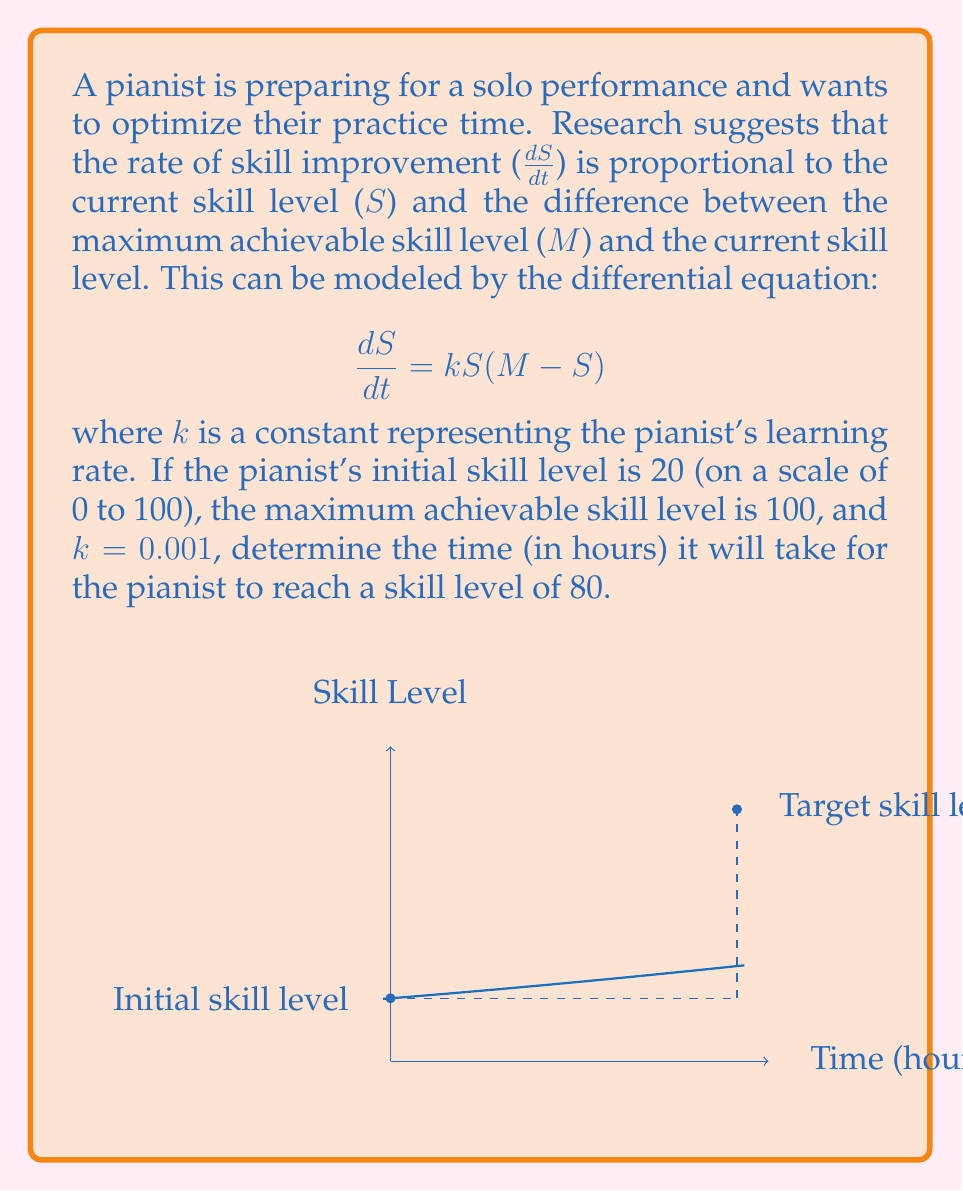Can you solve this math problem? Let's solve this problem step by step:

1) We start with the differential equation:
   $$\frac{dS}{dt} = kS(M-S)$$

2) This is a separable differential equation. We can rewrite it as:
   $$\frac{dS}{S(M-S)} = k dt$$

3) Integrating both sides:
   $$\int \frac{dS}{S(M-S)} = \int k dt$$

4) The left side can be integrated using partial fractions:
   $$\frac{1}{M} \ln|\frac{S}{M-S}| = kt + C$$

5) Solving for S:
   $$S = \frac{M}{1 + Ce^{-kMt}}$$

6) Using the initial condition $S(0) = 20$ and $M = 100$:
   $$20 = \frac{100}{1 + C}$$
   $$C = 4$$

7) So our solution is:
   $$S = \frac{100}{1 + 4e^{-0.1t}}$$

8) We want to find t when $S = 80$:
   $$80 = \frac{100}{1 + 4e^{-0.1t}}$$

9) Solving for t:
   $$1 + 4e^{-0.1t} = \frac{100}{80} = 1.25$$
   $$4e^{-0.1t} = 0.25$$
   $$e^{-0.1t} = 0.0625$$
   $$-0.1t = \ln(0.0625) = -2.7726$$
   $$t = 27.726$$

Therefore, it will take approximately 27.73 hours for the pianist to reach a skill level of 80.
Answer: 27.73 hours 